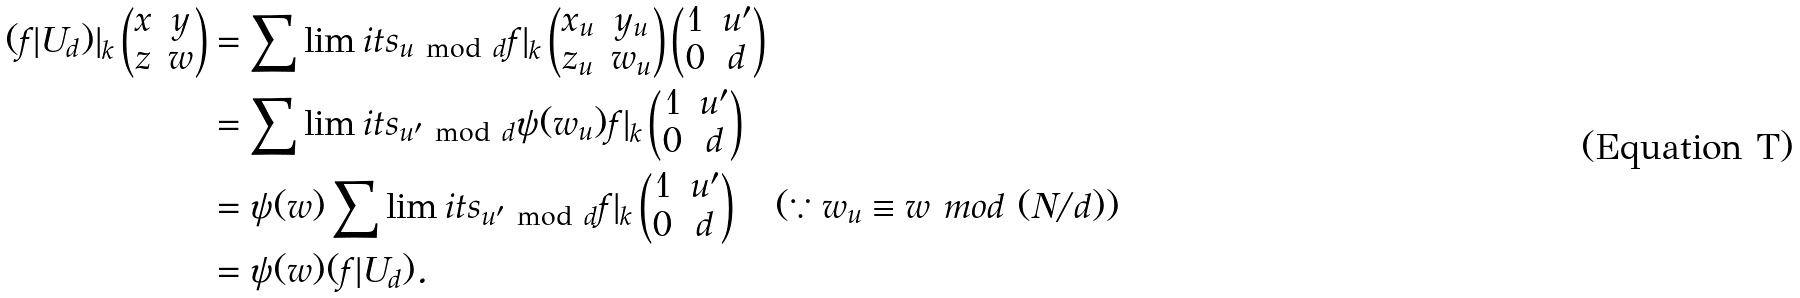Convert formula to latex. <formula><loc_0><loc_0><loc_500><loc_500>( f | U _ { d } ) | _ { k } \begin{pmatrix} x & y \\ z & w \end{pmatrix} & = \sum \lim i t s _ { u \ \text {mod} \ d } f | _ { k } \begin{pmatrix} x _ { u } & y _ { u } \\ z _ { u } & w _ { u } \end{pmatrix} \begin{pmatrix} 1 & u ^ { \prime } \\ 0 & d \end{pmatrix} \\ & = \sum \lim i t s _ { u ^ { \prime } \ \text {mod} \ d } \psi ( w _ { u } ) f | _ { k } \begin{pmatrix} 1 & u ^ { \prime } \\ 0 & d \end{pmatrix} \\ & = \psi ( w ) \sum \lim i t s _ { u ^ { \prime } \ \text {mod} \ d } f | _ { k } \begin{pmatrix} 1 & u ^ { \prime } \\ 0 & d \end{pmatrix} \quad ( \because w _ { u } \equiv w \ m o d \ ( N / d ) ) \\ & = \psi ( w ) ( f | U _ { d } ) .</formula> 